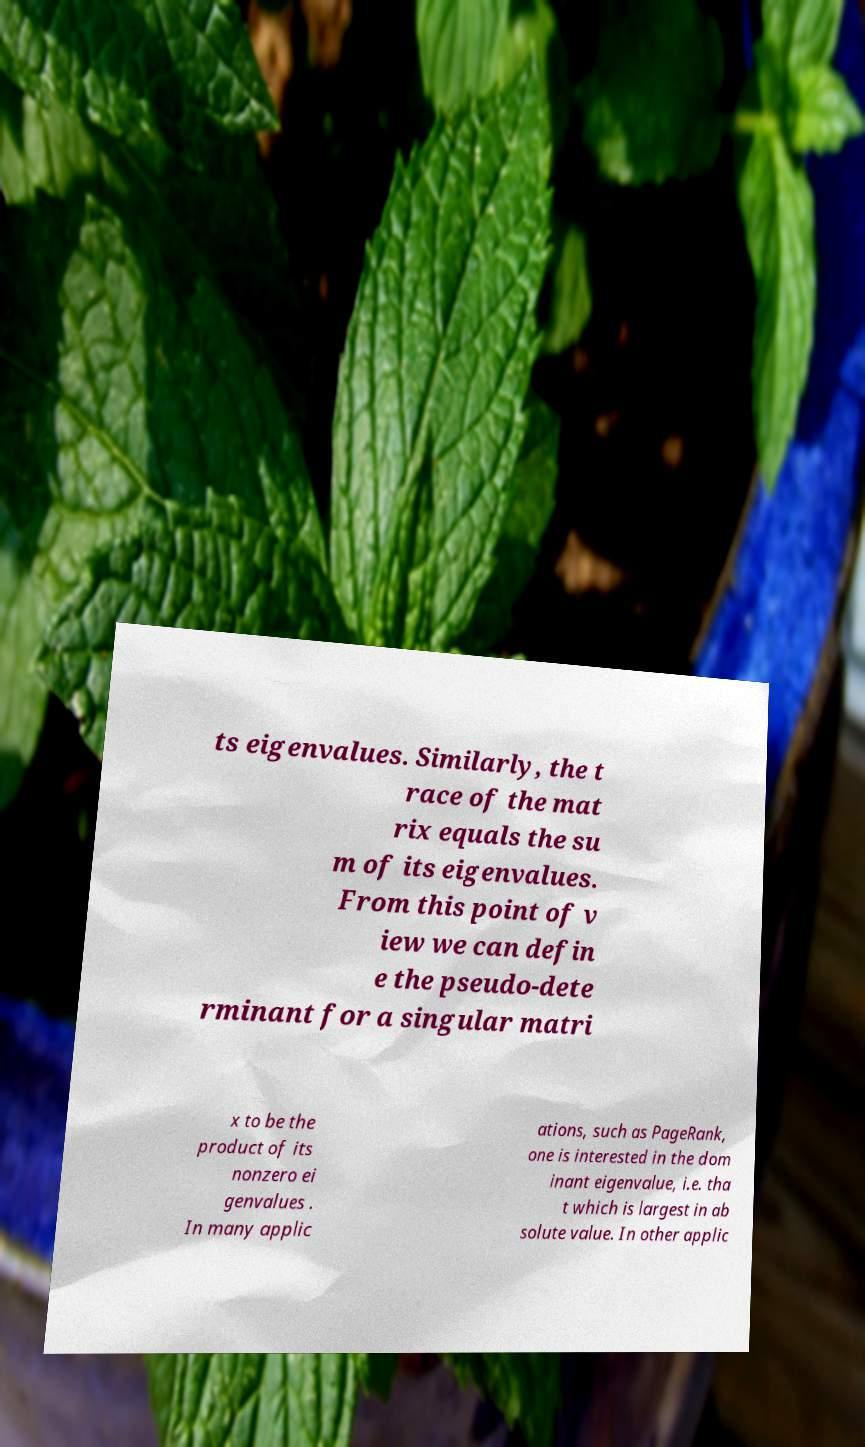Can you accurately transcribe the text from the provided image for me? ts eigenvalues. Similarly, the t race of the mat rix equals the su m of its eigenvalues. From this point of v iew we can defin e the pseudo-dete rminant for a singular matri x to be the product of its nonzero ei genvalues . In many applic ations, such as PageRank, one is interested in the dom inant eigenvalue, i.e. tha t which is largest in ab solute value. In other applic 